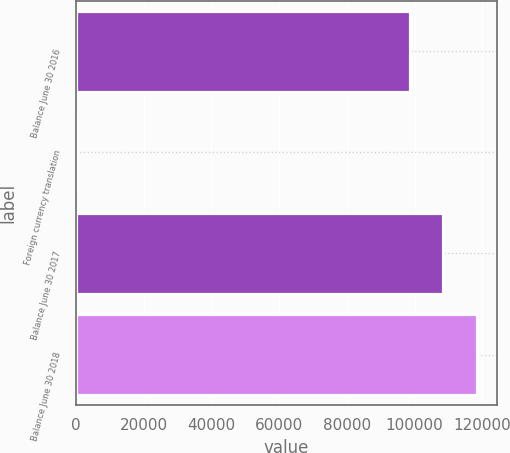<chart> <loc_0><loc_0><loc_500><loc_500><bar_chart><fcel>Balance June 30 2016<fcel>Foreign currency translation<fcel>Balance June 30 2017<fcel>Balance June 30 2018<nl><fcel>98634<fcel>8<fcel>108498<fcel>118362<nl></chart> 